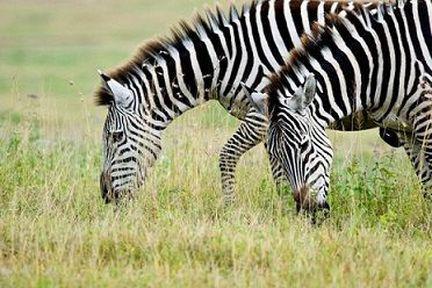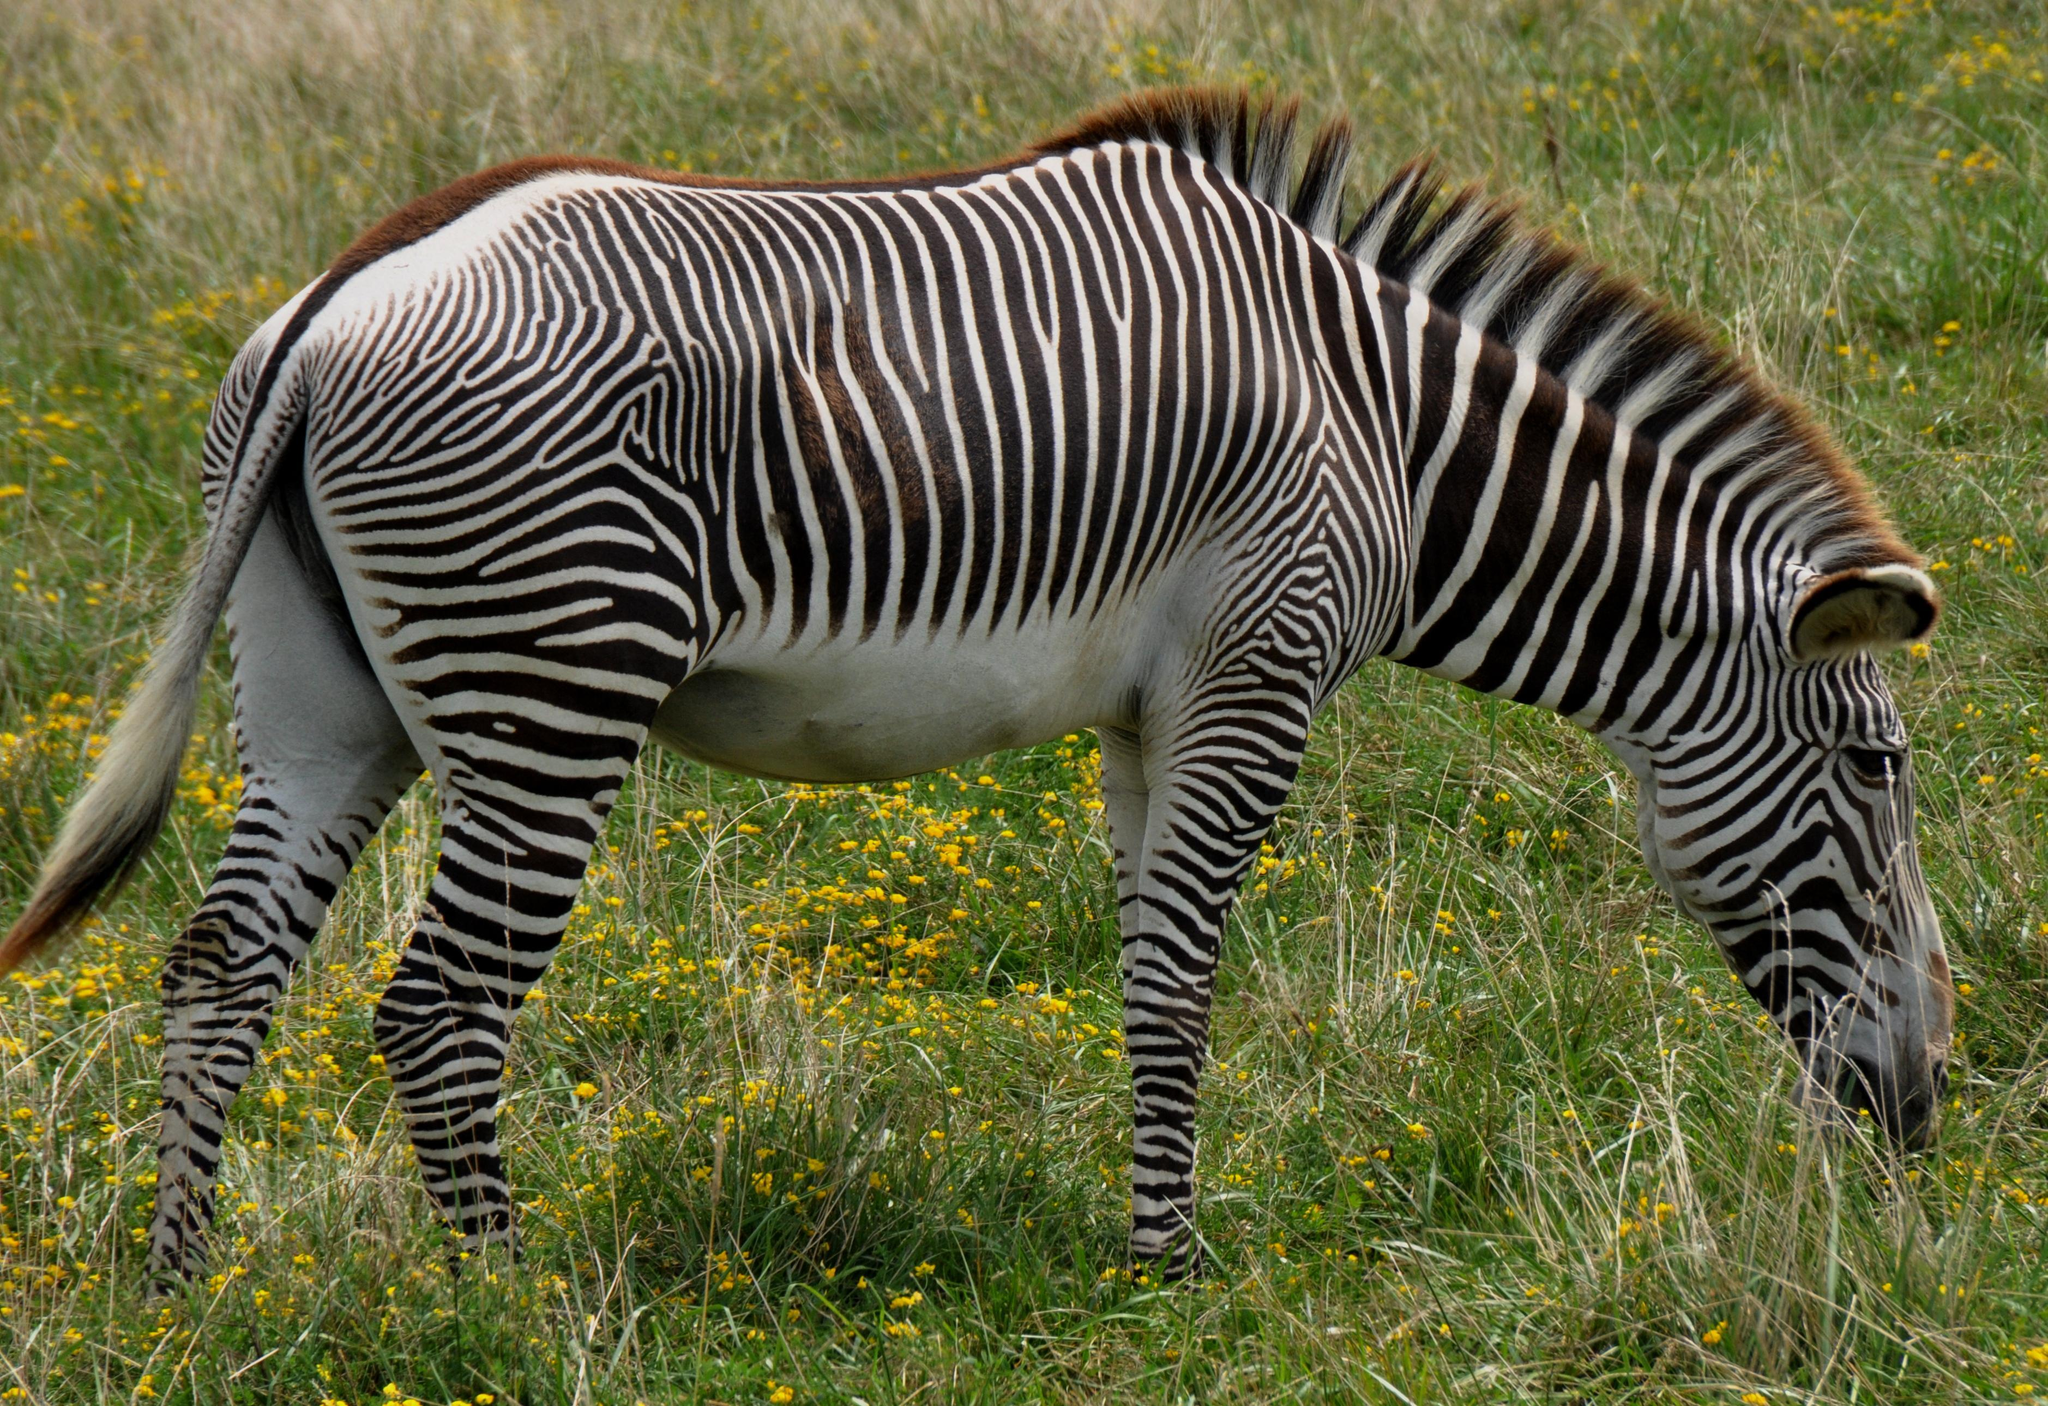The first image is the image on the left, the second image is the image on the right. Evaluate the accuracy of this statement regarding the images: "The right image contains one zebra with lowered head and body in profile, and the left image features two zebras side-to-side with bodies parallel.". Is it true? Answer yes or no. Yes. The first image is the image on the left, the second image is the image on the right. Given the left and right images, does the statement "Two zebras facing the same way are grazing in the grass." hold true? Answer yes or no. Yes. 